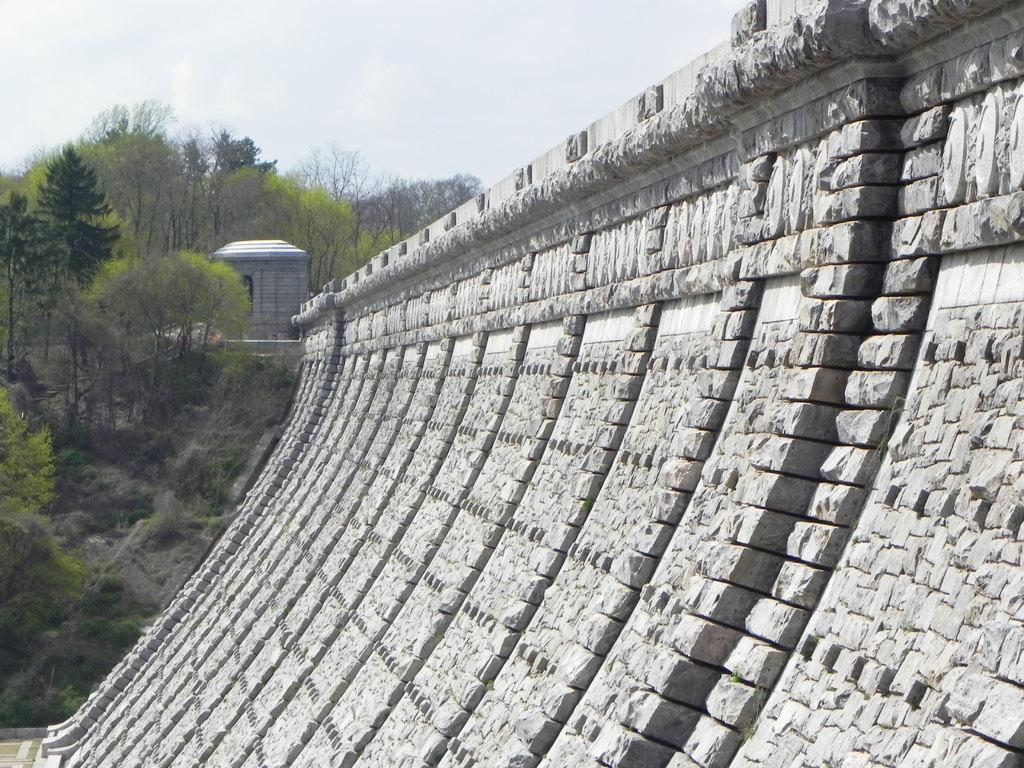What type of structure can be seen in the image? There is a wall in the image. What type of vegetation is present in the image? Creepers and trees are present in the image. What part of the natural environment is visible in the image? The sky is visible in the image. What type of table is set up in the image? There is no table present in the image. What type of pleasure can be seen being experienced by the people in the image? There are no people present in the image, so it is not possible to determine what type of pleasure they might be experiencing. 